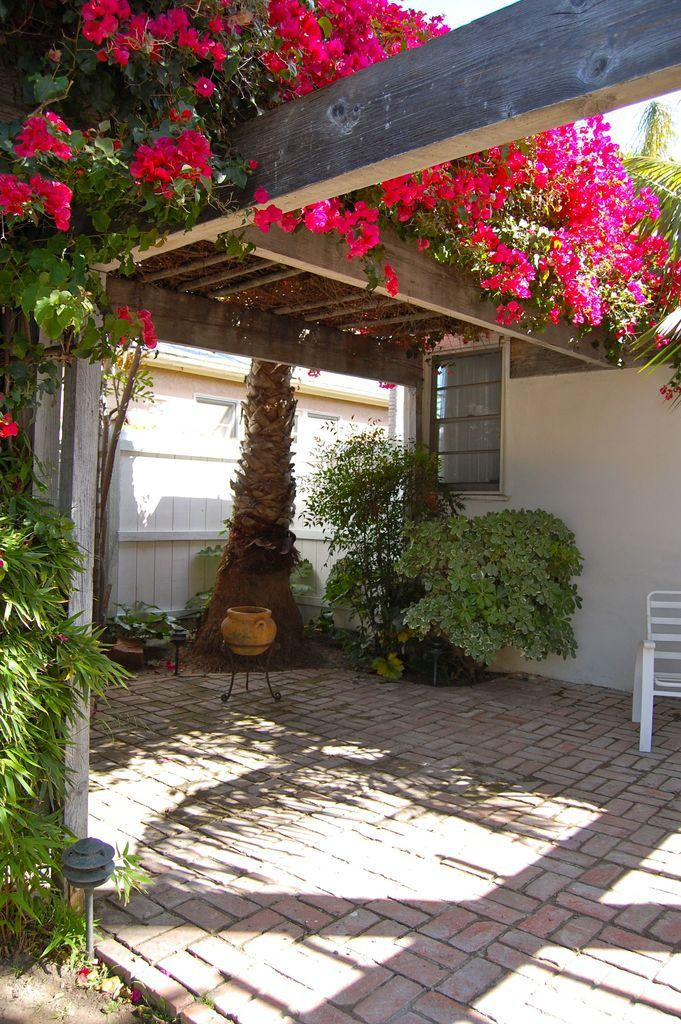What type of plants can be seen in the image? There are creepers and flowering plants in the image. What type of furniture is present in the image? There is a chair in the image. What type of container is present in the image? There is a pot in the image. What type of structure is present in the image? There is a shed in the image. What type of opening is present in the image? There is a window in the image. What type of natural element is present in the image? There is a tree in the image. What type of man-made structure is present in the image? There is a building in the image. What part of the natural environment is visible in the image? The sky is visible in the image. What time of day was the image likely taken? The image was likely taken during the day, as the sky is visible and there is no indication of darkness. What type of bells can be heard ringing in the image? There are no bells present in the image, and therefore no sound can be heard. What word is written on the tree in the image? There is no word written on the tree in the image. What type of jam is being served with the chair in the image? There is no jam present in the image, and the chair is not associated with any food or beverage. 